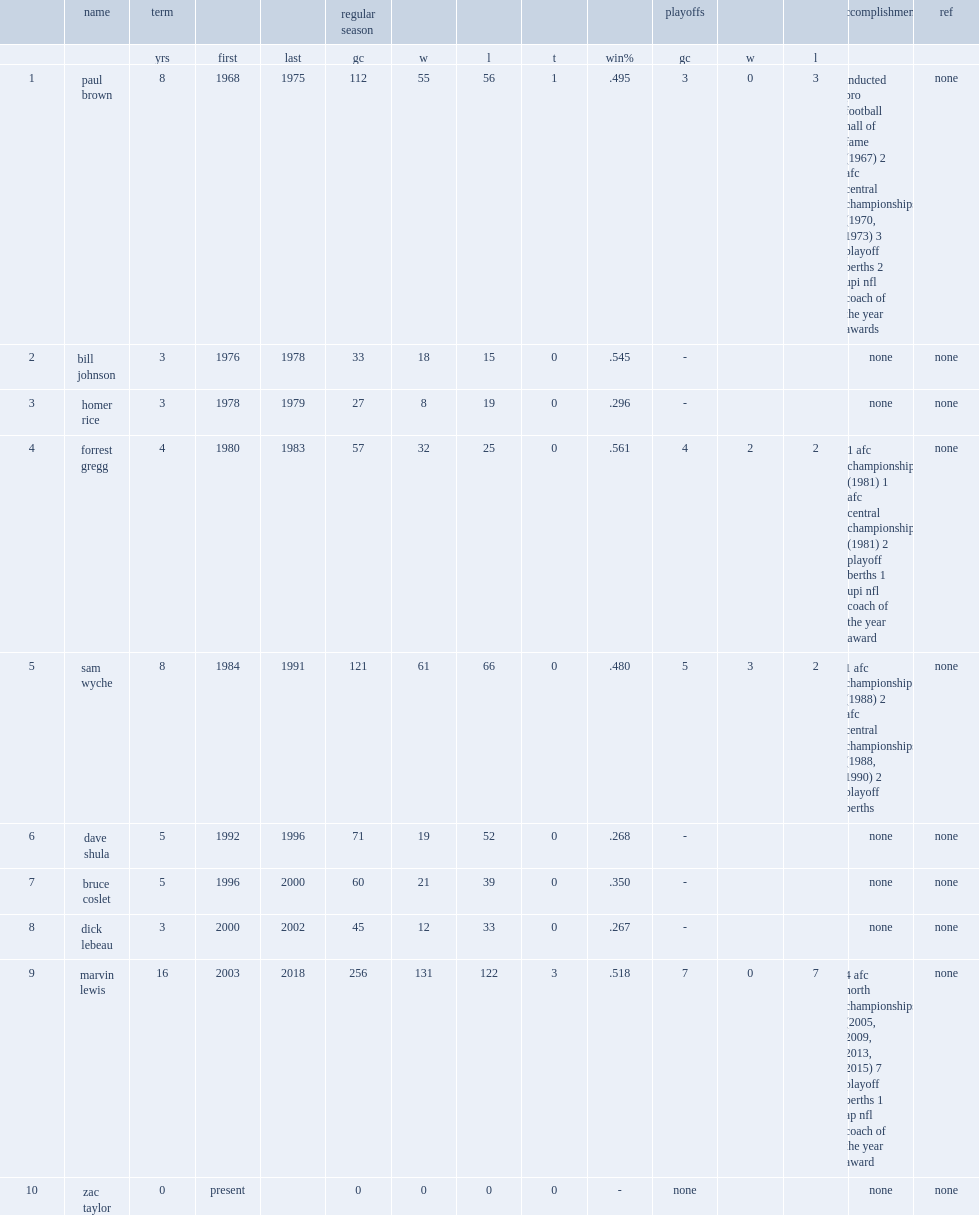When was the last year that marvin lewis was the head coach of the cincinnati bengals? 2018.0. 